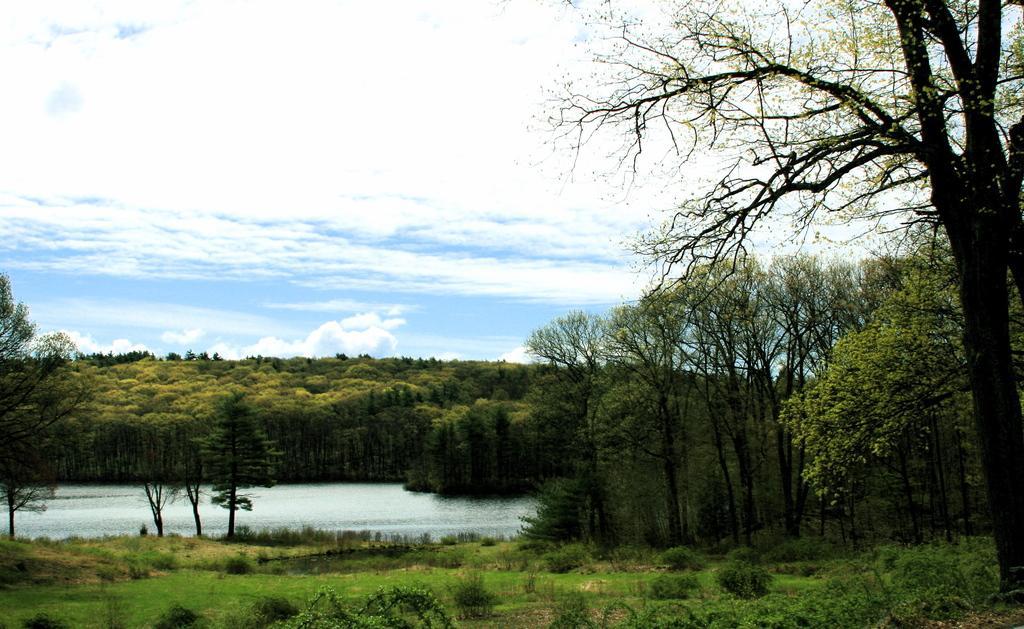In one or two sentences, can you explain what this image depicts? In this image we can see grass, plants, water and in the background of the image there are some trees, clear sky. 